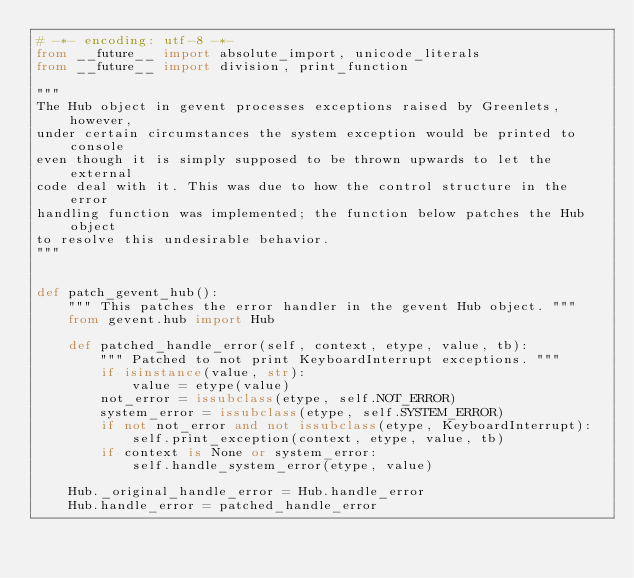<code> <loc_0><loc_0><loc_500><loc_500><_Python_># -*- encoding: utf-8 -*-
from __future__ import absolute_import, unicode_literals
from __future__ import division, print_function

"""
The Hub object in gevent processes exceptions raised by Greenlets, however,
under certain circumstances the system exception would be printed to console
even though it is simply supposed to be thrown upwards to let the external
code deal with it. This was due to how the control structure in the error
handling function was implemented; the function below patches the Hub object
to resolve this undesirable behavior.
"""


def patch_gevent_hub():
    """ This patches the error handler in the gevent Hub object. """
    from gevent.hub import Hub

    def patched_handle_error(self, context, etype, value, tb):
        """ Patched to not print KeyboardInterrupt exceptions. """
        if isinstance(value, str):
            value = etype(value)
        not_error = issubclass(etype, self.NOT_ERROR)
        system_error = issubclass(etype, self.SYSTEM_ERROR)
        if not not_error and not issubclass(etype, KeyboardInterrupt):
            self.print_exception(context, etype, value, tb)
        if context is None or system_error:
            self.handle_system_error(etype, value)

    Hub._original_handle_error = Hub.handle_error
    Hub.handle_error = patched_handle_error
</code> 